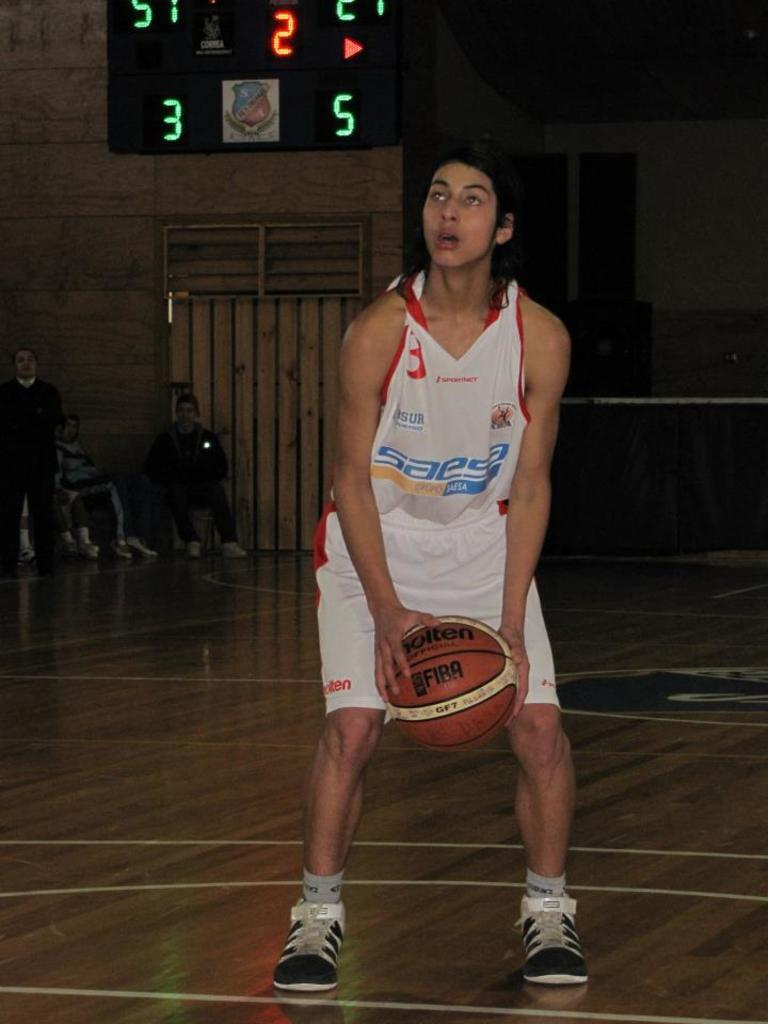<image>
Describe the image concisely. a person with a ball and a jesey that says saesa 